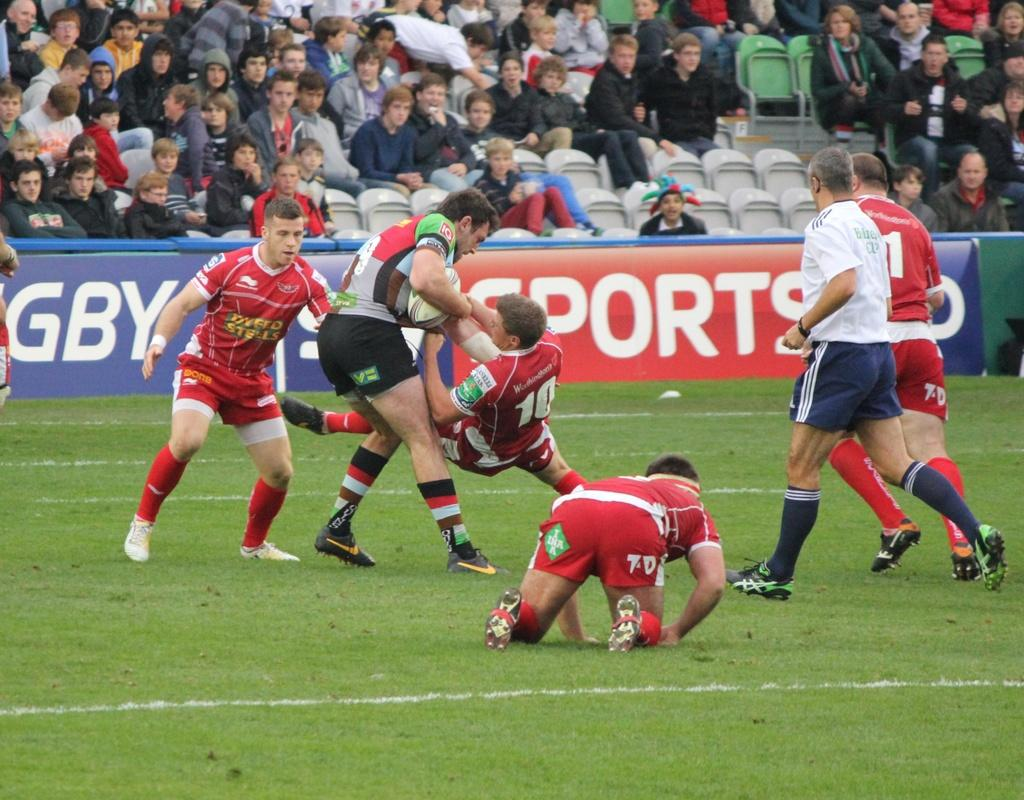<image>
Give a short and clear explanation of the subsequent image. Several rugby players, including some wearing red jerseys that say Dyfed Steel, are on the field. 